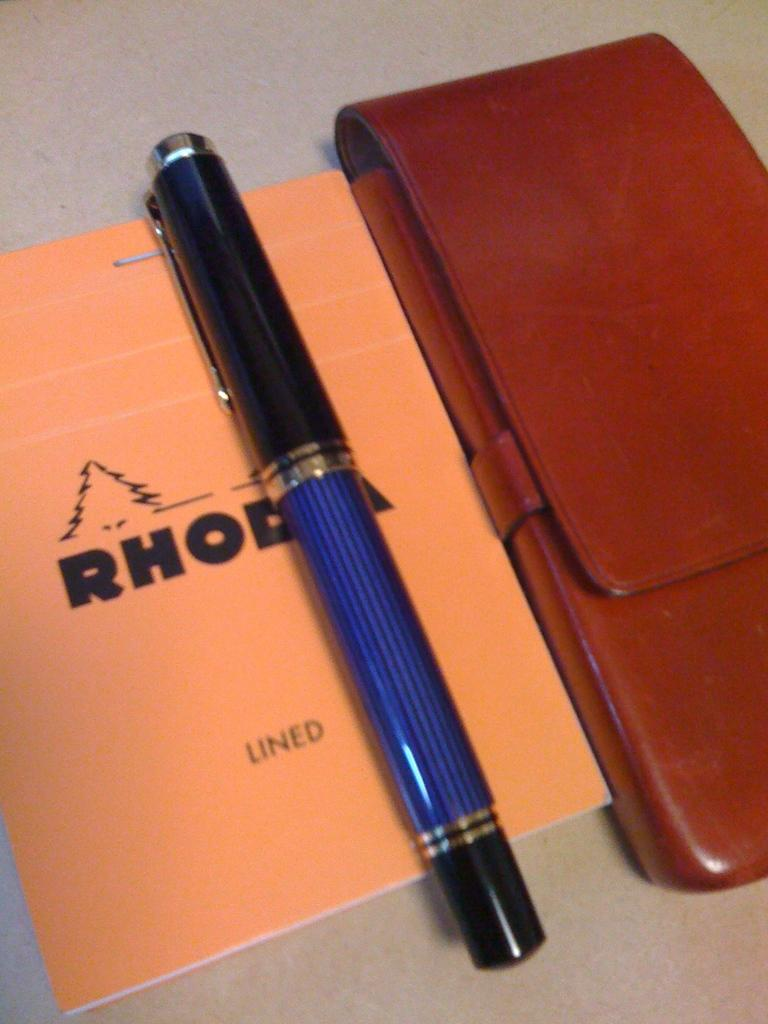What is one item visible in the image related to reading or writing? There is a book in the image, which is related to reading. What other item related to writing can be seen in the image? There is a pen in the image. Can you describe the object on a surface in the image? The object on a surface in the image is a book. What type of trail can be seen in the image? There is no trail present in the image. How many mice are visible in the image? There are no mice present in the image. 